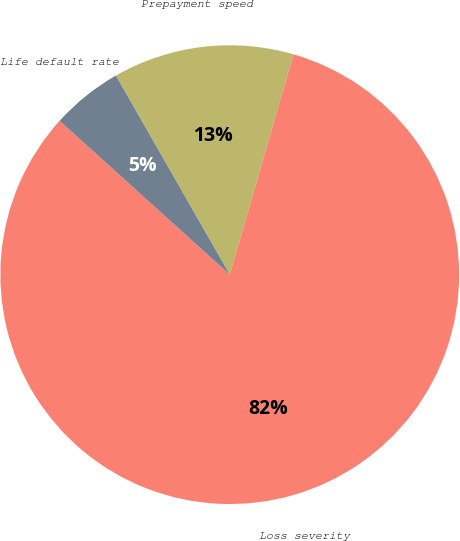<chart> <loc_0><loc_0><loc_500><loc_500><pie_chart><fcel>Prepayment speed<fcel>Loss severity<fcel>Life default rate<nl><fcel>12.75%<fcel>82.21%<fcel>5.03%<nl></chart> 